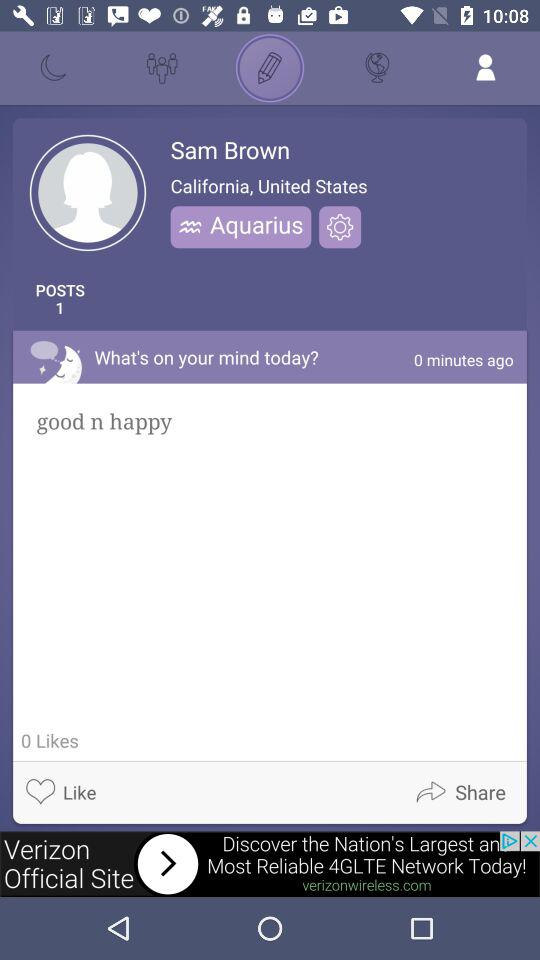How many likes are there? There are 0 likes. 